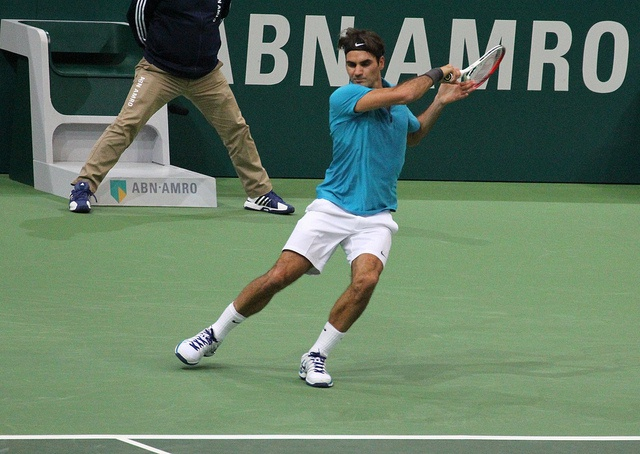Describe the objects in this image and their specific colors. I can see people in black, lavender, teal, and gray tones, people in black, darkgreen, and gray tones, chair in black, teal, and gray tones, and tennis racket in black, darkgray, white, and gray tones in this image. 